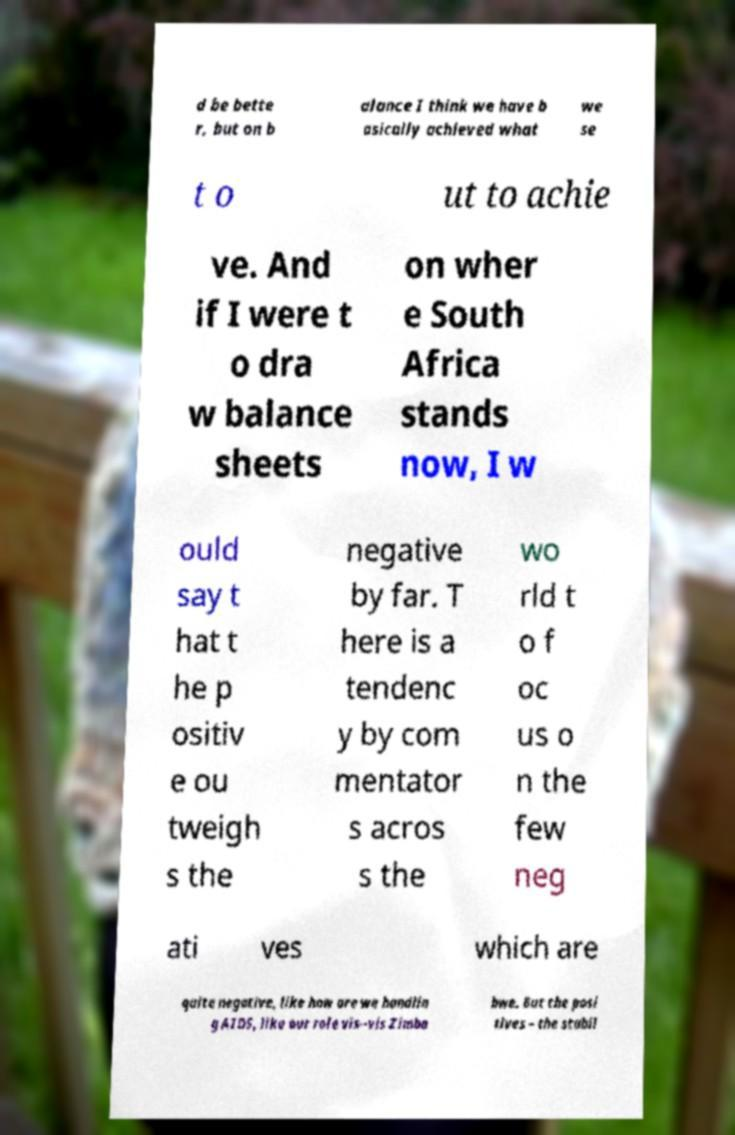Can you accurately transcribe the text from the provided image for me? d be bette r, but on b alance I think we have b asically achieved what we se t o ut to achie ve. And if I were t o dra w balance sheets on wher e South Africa stands now, I w ould say t hat t he p ositiv e ou tweigh s the negative by far. T here is a tendenc y by com mentator s acros s the wo rld t o f oc us o n the few neg ati ves which are quite negative, like how are we handlin g AIDS, like our role vis--vis Zimba bwe. But the posi tives – the stabil 